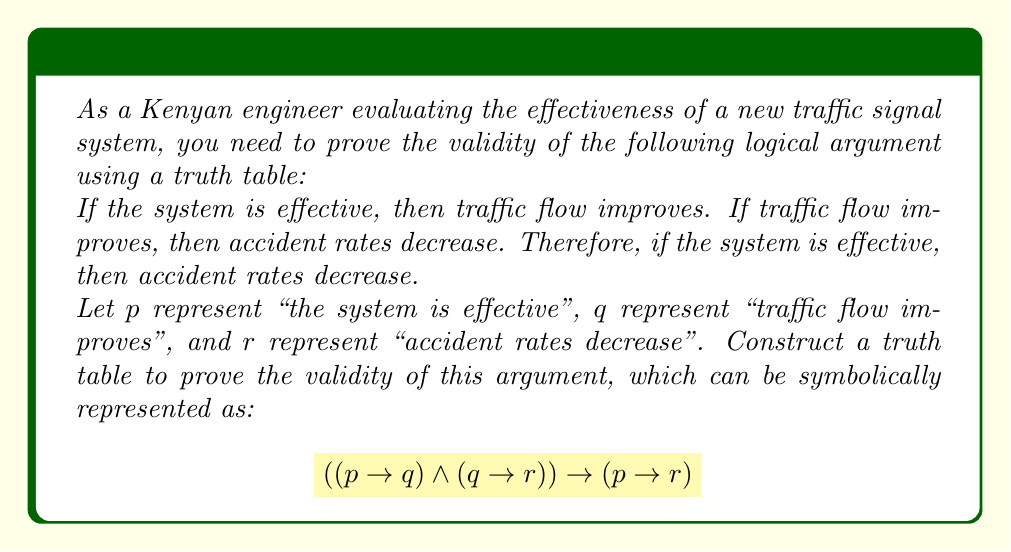Can you answer this question? To prove the validity of this logical argument using a truth table, we need to show that the conclusion $(p \rightarrow r)$ is true whenever the premises $(p \rightarrow q)$ and $(q \rightarrow r)$ are true. We'll construct a truth table with columns for $p$, $q$, $r$, $(p \rightarrow q)$, $(q \rightarrow r)$, and the final implication.

Step 1: Create the truth table with all possible combinations of truth values for $p$, $q$, and $r$.

Step 2: Evaluate $(p \rightarrow q)$ for each row.

Step 3: Evaluate $(q \rightarrow r)$ for each row.

Step 4: Evaluate $((p \rightarrow q) \land (q \rightarrow r))$ for each row.

Step 5: Evaluate $(p \rightarrow r)$ for each row.

Step 6: Evaluate the final implication $((p \rightarrow q) \land (q \rightarrow r)) \rightarrow (p \rightarrow r)$ for each row.

Here's the complete truth table:

$$
\begin{array}{ccc|cc|c|c|c}
p & q & r & (p \rightarrow q) & (q \rightarrow r) & ((p \rightarrow q) \land (q \rightarrow r)) & (p \rightarrow r) & ((p \rightarrow q) \land (q \rightarrow r)) \rightarrow (p \rightarrow r) \\
\hline
T & T & T & T & T & T & T & T \\
T & T & F & T & F & F & F & T \\
T & F & T & F & T & F & T & T \\
T & F & F & F & T & F & F & T \\
F & T & T & T & T & T & T & T \\
F & T & F & T & F & F & T & T \\
F & F & T & T & T & T & T & T \\
F & F & F & T & T & T & T & T \\
\end{array}
$$

As we can see from the truth table, the final column contains only true values (T). This means that regardless of the truth values of $p$, $q$, and $r$, the conclusion $(p \rightarrow r)$ is always true when the premises $(p \rightarrow q)$ and $(q \rightarrow r)$ are true. Therefore, the argument is valid.
Answer: The logical argument is valid. The truth table shows that the final implication $((p \rightarrow q) \land (q \rightarrow r)) \rightarrow (p \rightarrow r)$ is true for all possible combinations of truth values for $p$, $q$, and $r$, proving the validity of the argument. 